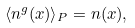<formula> <loc_0><loc_0><loc_500><loc_500>\langle n ^ { g } ( { x } ) \rangle _ { P } = n ( { x } ) ,</formula> 